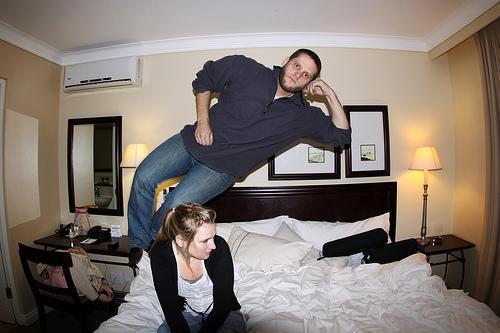How many people are there?
Give a very brief answer. 2. 